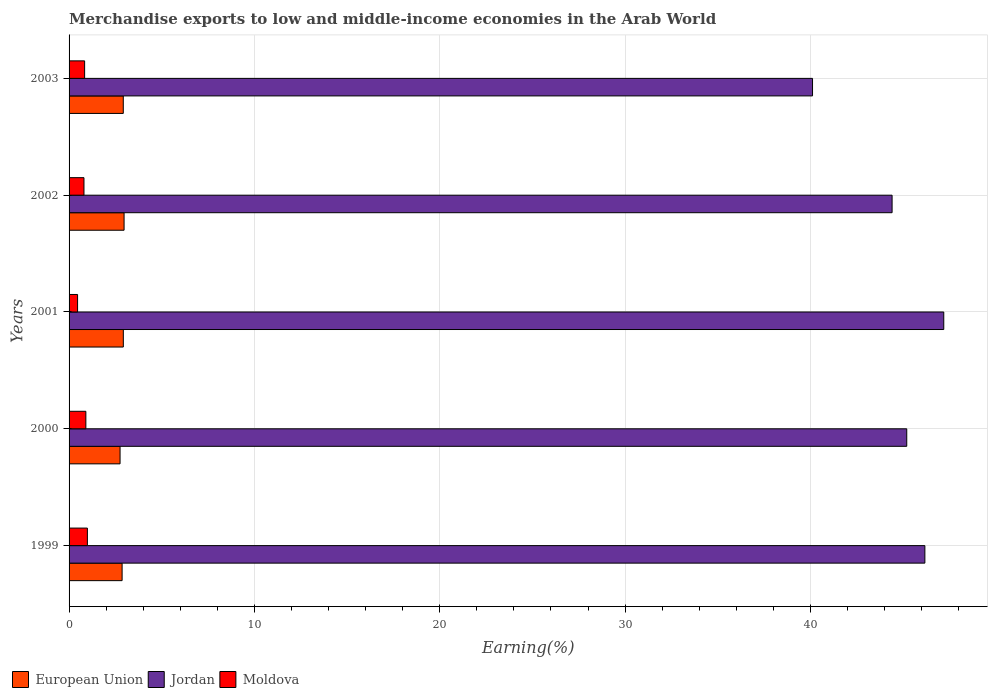Are the number of bars per tick equal to the number of legend labels?
Offer a very short reply. Yes. How many bars are there on the 1st tick from the top?
Provide a succinct answer. 3. What is the label of the 5th group of bars from the top?
Your answer should be compact. 1999. What is the percentage of amount earned from merchandise exports in European Union in 1999?
Your response must be concise. 2.86. Across all years, what is the maximum percentage of amount earned from merchandise exports in Jordan?
Provide a short and direct response. 47.19. Across all years, what is the minimum percentage of amount earned from merchandise exports in Jordan?
Make the answer very short. 40.11. In which year was the percentage of amount earned from merchandise exports in Jordan maximum?
Offer a very short reply. 2001. In which year was the percentage of amount earned from merchandise exports in Moldova minimum?
Provide a short and direct response. 2001. What is the total percentage of amount earned from merchandise exports in Jordan in the graph?
Offer a terse response. 223.09. What is the difference between the percentage of amount earned from merchandise exports in European Union in 2000 and that in 2002?
Provide a succinct answer. -0.22. What is the difference between the percentage of amount earned from merchandise exports in European Union in 2000 and the percentage of amount earned from merchandise exports in Jordan in 2001?
Your response must be concise. -44.44. What is the average percentage of amount earned from merchandise exports in Moldova per year?
Offer a terse response. 0.8. In the year 2001, what is the difference between the percentage of amount earned from merchandise exports in Jordan and percentage of amount earned from merchandise exports in European Union?
Your answer should be compact. 44.27. In how many years, is the percentage of amount earned from merchandise exports in European Union greater than 42 %?
Keep it short and to the point. 0. What is the ratio of the percentage of amount earned from merchandise exports in European Union in 1999 to that in 2002?
Your answer should be very brief. 0.96. Is the difference between the percentage of amount earned from merchandise exports in Jordan in 2000 and 2001 greater than the difference between the percentage of amount earned from merchandise exports in European Union in 2000 and 2001?
Your response must be concise. No. What is the difference between the highest and the second highest percentage of amount earned from merchandise exports in Jordan?
Provide a succinct answer. 1.02. What is the difference between the highest and the lowest percentage of amount earned from merchandise exports in Moldova?
Ensure brevity in your answer.  0.53. Is the sum of the percentage of amount earned from merchandise exports in European Union in 1999 and 2002 greater than the maximum percentage of amount earned from merchandise exports in Moldova across all years?
Your answer should be very brief. Yes. What does the 1st bar from the top in 1999 represents?
Provide a short and direct response. Moldova. What does the 2nd bar from the bottom in 2001 represents?
Keep it short and to the point. Jordan. How many bars are there?
Your answer should be very brief. 15. How many years are there in the graph?
Provide a succinct answer. 5. What is the difference between two consecutive major ticks on the X-axis?
Give a very brief answer. 10. Are the values on the major ticks of X-axis written in scientific E-notation?
Offer a very short reply. No. Does the graph contain any zero values?
Give a very brief answer. No. Does the graph contain grids?
Provide a short and direct response. Yes. Where does the legend appear in the graph?
Your answer should be very brief. Bottom left. How many legend labels are there?
Your answer should be compact. 3. What is the title of the graph?
Your answer should be very brief. Merchandise exports to low and middle-income economies in the Arab World. Does "Arab World" appear as one of the legend labels in the graph?
Your answer should be very brief. No. What is the label or title of the X-axis?
Offer a very short reply. Earning(%). What is the Earning(%) in European Union in 1999?
Offer a terse response. 2.86. What is the Earning(%) of Jordan in 1999?
Give a very brief answer. 46.18. What is the Earning(%) of Moldova in 1999?
Offer a terse response. 0.99. What is the Earning(%) of European Union in 2000?
Provide a succinct answer. 2.75. What is the Earning(%) in Jordan in 2000?
Ensure brevity in your answer.  45.2. What is the Earning(%) of Moldova in 2000?
Provide a succinct answer. 0.91. What is the Earning(%) of European Union in 2001?
Give a very brief answer. 2.93. What is the Earning(%) in Jordan in 2001?
Make the answer very short. 47.19. What is the Earning(%) of Moldova in 2001?
Keep it short and to the point. 0.46. What is the Earning(%) in European Union in 2002?
Your answer should be very brief. 2.97. What is the Earning(%) in Jordan in 2002?
Your response must be concise. 44.41. What is the Earning(%) of Moldova in 2002?
Your answer should be compact. 0.8. What is the Earning(%) in European Union in 2003?
Offer a terse response. 2.92. What is the Earning(%) of Jordan in 2003?
Your response must be concise. 40.11. What is the Earning(%) in Moldova in 2003?
Offer a terse response. 0.84. Across all years, what is the maximum Earning(%) in European Union?
Provide a succinct answer. 2.97. Across all years, what is the maximum Earning(%) of Jordan?
Offer a very short reply. 47.19. Across all years, what is the maximum Earning(%) of Moldova?
Your answer should be very brief. 0.99. Across all years, what is the minimum Earning(%) in European Union?
Offer a terse response. 2.75. Across all years, what is the minimum Earning(%) in Jordan?
Your answer should be compact. 40.11. Across all years, what is the minimum Earning(%) of Moldova?
Offer a very short reply. 0.46. What is the total Earning(%) in European Union in the graph?
Ensure brevity in your answer.  14.43. What is the total Earning(%) of Jordan in the graph?
Make the answer very short. 223.09. What is the total Earning(%) in Moldova in the graph?
Offer a very short reply. 4. What is the difference between the Earning(%) in European Union in 1999 and that in 2000?
Give a very brief answer. 0.11. What is the difference between the Earning(%) in Jordan in 1999 and that in 2000?
Offer a very short reply. 0.98. What is the difference between the Earning(%) in Moldova in 1999 and that in 2000?
Offer a very short reply. 0.08. What is the difference between the Earning(%) in European Union in 1999 and that in 2001?
Provide a short and direct response. -0.07. What is the difference between the Earning(%) of Jordan in 1999 and that in 2001?
Ensure brevity in your answer.  -1.02. What is the difference between the Earning(%) in Moldova in 1999 and that in 2001?
Keep it short and to the point. 0.53. What is the difference between the Earning(%) of European Union in 1999 and that in 2002?
Provide a short and direct response. -0.11. What is the difference between the Earning(%) in Jordan in 1999 and that in 2002?
Give a very brief answer. 1.77. What is the difference between the Earning(%) in Moldova in 1999 and that in 2002?
Ensure brevity in your answer.  0.19. What is the difference between the Earning(%) in European Union in 1999 and that in 2003?
Your response must be concise. -0.06. What is the difference between the Earning(%) of Jordan in 1999 and that in 2003?
Your answer should be compact. 6.06. What is the difference between the Earning(%) of Moldova in 1999 and that in 2003?
Offer a terse response. 0.15. What is the difference between the Earning(%) of European Union in 2000 and that in 2001?
Keep it short and to the point. -0.18. What is the difference between the Earning(%) of Jordan in 2000 and that in 2001?
Make the answer very short. -2. What is the difference between the Earning(%) in Moldova in 2000 and that in 2001?
Offer a very short reply. 0.45. What is the difference between the Earning(%) in European Union in 2000 and that in 2002?
Keep it short and to the point. -0.22. What is the difference between the Earning(%) in Jordan in 2000 and that in 2002?
Give a very brief answer. 0.79. What is the difference between the Earning(%) of Moldova in 2000 and that in 2002?
Your answer should be compact. 0.1. What is the difference between the Earning(%) of European Union in 2000 and that in 2003?
Your response must be concise. -0.17. What is the difference between the Earning(%) of Jordan in 2000 and that in 2003?
Give a very brief answer. 5.08. What is the difference between the Earning(%) of Moldova in 2000 and that in 2003?
Offer a terse response. 0.07. What is the difference between the Earning(%) in European Union in 2001 and that in 2002?
Make the answer very short. -0.04. What is the difference between the Earning(%) in Jordan in 2001 and that in 2002?
Keep it short and to the point. 2.79. What is the difference between the Earning(%) of Moldova in 2001 and that in 2002?
Keep it short and to the point. -0.34. What is the difference between the Earning(%) in European Union in 2001 and that in 2003?
Provide a short and direct response. 0. What is the difference between the Earning(%) in Jordan in 2001 and that in 2003?
Provide a short and direct response. 7.08. What is the difference between the Earning(%) in Moldova in 2001 and that in 2003?
Keep it short and to the point. -0.38. What is the difference between the Earning(%) of European Union in 2002 and that in 2003?
Your response must be concise. 0.04. What is the difference between the Earning(%) in Jordan in 2002 and that in 2003?
Offer a terse response. 4.29. What is the difference between the Earning(%) of Moldova in 2002 and that in 2003?
Your answer should be very brief. -0.04. What is the difference between the Earning(%) of European Union in 1999 and the Earning(%) of Jordan in 2000?
Provide a succinct answer. -42.34. What is the difference between the Earning(%) of European Union in 1999 and the Earning(%) of Moldova in 2000?
Your response must be concise. 1.96. What is the difference between the Earning(%) in Jordan in 1999 and the Earning(%) in Moldova in 2000?
Offer a terse response. 45.27. What is the difference between the Earning(%) of European Union in 1999 and the Earning(%) of Jordan in 2001?
Provide a short and direct response. -44.33. What is the difference between the Earning(%) of European Union in 1999 and the Earning(%) of Moldova in 2001?
Give a very brief answer. 2.4. What is the difference between the Earning(%) of Jordan in 1999 and the Earning(%) of Moldova in 2001?
Your response must be concise. 45.72. What is the difference between the Earning(%) of European Union in 1999 and the Earning(%) of Jordan in 2002?
Give a very brief answer. -41.55. What is the difference between the Earning(%) of European Union in 1999 and the Earning(%) of Moldova in 2002?
Your answer should be compact. 2.06. What is the difference between the Earning(%) in Jordan in 1999 and the Earning(%) in Moldova in 2002?
Offer a terse response. 45.37. What is the difference between the Earning(%) of European Union in 1999 and the Earning(%) of Jordan in 2003?
Provide a succinct answer. -37.25. What is the difference between the Earning(%) in European Union in 1999 and the Earning(%) in Moldova in 2003?
Your response must be concise. 2.02. What is the difference between the Earning(%) of Jordan in 1999 and the Earning(%) of Moldova in 2003?
Give a very brief answer. 45.34. What is the difference between the Earning(%) in European Union in 2000 and the Earning(%) in Jordan in 2001?
Your response must be concise. -44.44. What is the difference between the Earning(%) of European Union in 2000 and the Earning(%) of Moldova in 2001?
Provide a short and direct response. 2.29. What is the difference between the Earning(%) in Jordan in 2000 and the Earning(%) in Moldova in 2001?
Keep it short and to the point. 44.74. What is the difference between the Earning(%) of European Union in 2000 and the Earning(%) of Jordan in 2002?
Give a very brief answer. -41.66. What is the difference between the Earning(%) in European Union in 2000 and the Earning(%) in Moldova in 2002?
Your answer should be very brief. 1.95. What is the difference between the Earning(%) in Jordan in 2000 and the Earning(%) in Moldova in 2002?
Your answer should be very brief. 44.39. What is the difference between the Earning(%) in European Union in 2000 and the Earning(%) in Jordan in 2003?
Your answer should be very brief. -37.36. What is the difference between the Earning(%) of European Union in 2000 and the Earning(%) of Moldova in 2003?
Your answer should be compact. 1.91. What is the difference between the Earning(%) in Jordan in 2000 and the Earning(%) in Moldova in 2003?
Provide a short and direct response. 44.36. What is the difference between the Earning(%) in European Union in 2001 and the Earning(%) in Jordan in 2002?
Keep it short and to the point. -41.48. What is the difference between the Earning(%) of European Union in 2001 and the Earning(%) of Moldova in 2002?
Make the answer very short. 2.12. What is the difference between the Earning(%) in Jordan in 2001 and the Earning(%) in Moldova in 2002?
Offer a very short reply. 46.39. What is the difference between the Earning(%) of European Union in 2001 and the Earning(%) of Jordan in 2003?
Provide a succinct answer. -37.19. What is the difference between the Earning(%) of European Union in 2001 and the Earning(%) of Moldova in 2003?
Ensure brevity in your answer.  2.09. What is the difference between the Earning(%) in Jordan in 2001 and the Earning(%) in Moldova in 2003?
Offer a terse response. 46.36. What is the difference between the Earning(%) in European Union in 2002 and the Earning(%) in Jordan in 2003?
Your response must be concise. -37.15. What is the difference between the Earning(%) of European Union in 2002 and the Earning(%) of Moldova in 2003?
Your answer should be compact. 2.13. What is the difference between the Earning(%) of Jordan in 2002 and the Earning(%) of Moldova in 2003?
Your answer should be very brief. 43.57. What is the average Earning(%) of European Union per year?
Offer a terse response. 2.89. What is the average Earning(%) of Jordan per year?
Offer a very short reply. 44.62. What is the average Earning(%) in Moldova per year?
Your response must be concise. 0.8. In the year 1999, what is the difference between the Earning(%) in European Union and Earning(%) in Jordan?
Offer a very short reply. -43.31. In the year 1999, what is the difference between the Earning(%) of European Union and Earning(%) of Moldova?
Your answer should be compact. 1.87. In the year 1999, what is the difference between the Earning(%) in Jordan and Earning(%) in Moldova?
Ensure brevity in your answer.  45.19. In the year 2000, what is the difference between the Earning(%) of European Union and Earning(%) of Jordan?
Offer a very short reply. -42.45. In the year 2000, what is the difference between the Earning(%) in European Union and Earning(%) in Moldova?
Make the answer very short. 1.85. In the year 2000, what is the difference between the Earning(%) of Jordan and Earning(%) of Moldova?
Provide a short and direct response. 44.29. In the year 2001, what is the difference between the Earning(%) of European Union and Earning(%) of Jordan?
Offer a very short reply. -44.27. In the year 2001, what is the difference between the Earning(%) in European Union and Earning(%) in Moldova?
Your answer should be compact. 2.47. In the year 2001, what is the difference between the Earning(%) of Jordan and Earning(%) of Moldova?
Give a very brief answer. 46.74. In the year 2002, what is the difference between the Earning(%) of European Union and Earning(%) of Jordan?
Your response must be concise. -41.44. In the year 2002, what is the difference between the Earning(%) of European Union and Earning(%) of Moldova?
Ensure brevity in your answer.  2.16. In the year 2002, what is the difference between the Earning(%) of Jordan and Earning(%) of Moldova?
Ensure brevity in your answer.  43.6. In the year 2003, what is the difference between the Earning(%) in European Union and Earning(%) in Jordan?
Keep it short and to the point. -37.19. In the year 2003, what is the difference between the Earning(%) of European Union and Earning(%) of Moldova?
Make the answer very short. 2.09. In the year 2003, what is the difference between the Earning(%) of Jordan and Earning(%) of Moldova?
Your answer should be very brief. 39.28. What is the ratio of the Earning(%) in European Union in 1999 to that in 2000?
Give a very brief answer. 1.04. What is the ratio of the Earning(%) of Jordan in 1999 to that in 2000?
Provide a short and direct response. 1.02. What is the ratio of the Earning(%) of Moldova in 1999 to that in 2000?
Your response must be concise. 1.09. What is the ratio of the Earning(%) of European Union in 1999 to that in 2001?
Make the answer very short. 0.98. What is the ratio of the Earning(%) of Jordan in 1999 to that in 2001?
Ensure brevity in your answer.  0.98. What is the ratio of the Earning(%) of Moldova in 1999 to that in 2001?
Ensure brevity in your answer.  2.15. What is the ratio of the Earning(%) in European Union in 1999 to that in 2002?
Your response must be concise. 0.96. What is the ratio of the Earning(%) in Jordan in 1999 to that in 2002?
Offer a terse response. 1.04. What is the ratio of the Earning(%) in Moldova in 1999 to that in 2002?
Your answer should be very brief. 1.23. What is the ratio of the Earning(%) in European Union in 1999 to that in 2003?
Ensure brevity in your answer.  0.98. What is the ratio of the Earning(%) of Jordan in 1999 to that in 2003?
Ensure brevity in your answer.  1.15. What is the ratio of the Earning(%) in Moldova in 1999 to that in 2003?
Give a very brief answer. 1.18. What is the ratio of the Earning(%) in European Union in 2000 to that in 2001?
Your answer should be compact. 0.94. What is the ratio of the Earning(%) of Jordan in 2000 to that in 2001?
Give a very brief answer. 0.96. What is the ratio of the Earning(%) in Moldova in 2000 to that in 2001?
Offer a very short reply. 1.97. What is the ratio of the Earning(%) in European Union in 2000 to that in 2002?
Give a very brief answer. 0.93. What is the ratio of the Earning(%) of Jordan in 2000 to that in 2002?
Your response must be concise. 1.02. What is the ratio of the Earning(%) in Moldova in 2000 to that in 2002?
Ensure brevity in your answer.  1.13. What is the ratio of the Earning(%) in European Union in 2000 to that in 2003?
Give a very brief answer. 0.94. What is the ratio of the Earning(%) in Jordan in 2000 to that in 2003?
Keep it short and to the point. 1.13. What is the ratio of the Earning(%) of Moldova in 2000 to that in 2003?
Keep it short and to the point. 1.08. What is the ratio of the Earning(%) of European Union in 2001 to that in 2002?
Make the answer very short. 0.99. What is the ratio of the Earning(%) of Jordan in 2001 to that in 2002?
Provide a short and direct response. 1.06. What is the ratio of the Earning(%) in Moldova in 2001 to that in 2002?
Ensure brevity in your answer.  0.57. What is the ratio of the Earning(%) in European Union in 2001 to that in 2003?
Provide a succinct answer. 1. What is the ratio of the Earning(%) of Jordan in 2001 to that in 2003?
Keep it short and to the point. 1.18. What is the ratio of the Earning(%) of Moldova in 2001 to that in 2003?
Provide a succinct answer. 0.55. What is the ratio of the Earning(%) in European Union in 2002 to that in 2003?
Give a very brief answer. 1.01. What is the ratio of the Earning(%) of Jordan in 2002 to that in 2003?
Keep it short and to the point. 1.11. What is the ratio of the Earning(%) of Moldova in 2002 to that in 2003?
Offer a terse response. 0.96. What is the difference between the highest and the second highest Earning(%) of European Union?
Your answer should be very brief. 0.04. What is the difference between the highest and the second highest Earning(%) in Jordan?
Provide a succinct answer. 1.02. What is the difference between the highest and the second highest Earning(%) of Moldova?
Your answer should be very brief. 0.08. What is the difference between the highest and the lowest Earning(%) of European Union?
Provide a short and direct response. 0.22. What is the difference between the highest and the lowest Earning(%) in Jordan?
Offer a very short reply. 7.08. What is the difference between the highest and the lowest Earning(%) of Moldova?
Your answer should be very brief. 0.53. 